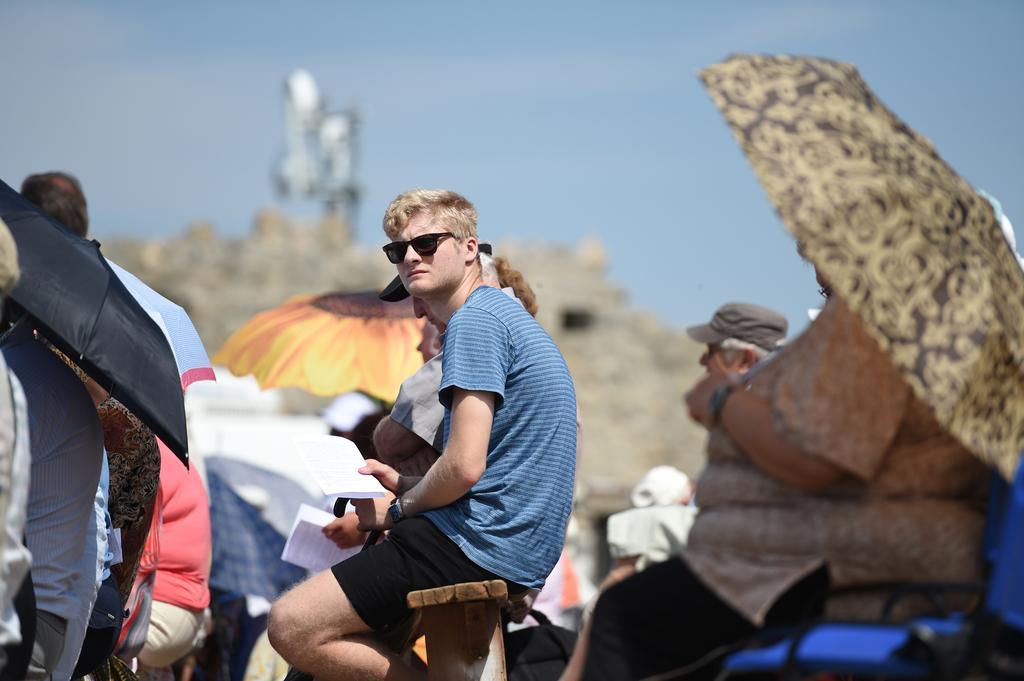In one or two sentences, can you explain what this image depicts? In the center of the image we can see people sitting and some of them are holding umbrellas. The man sitting in the center is holding papers. In the background there is sky. 